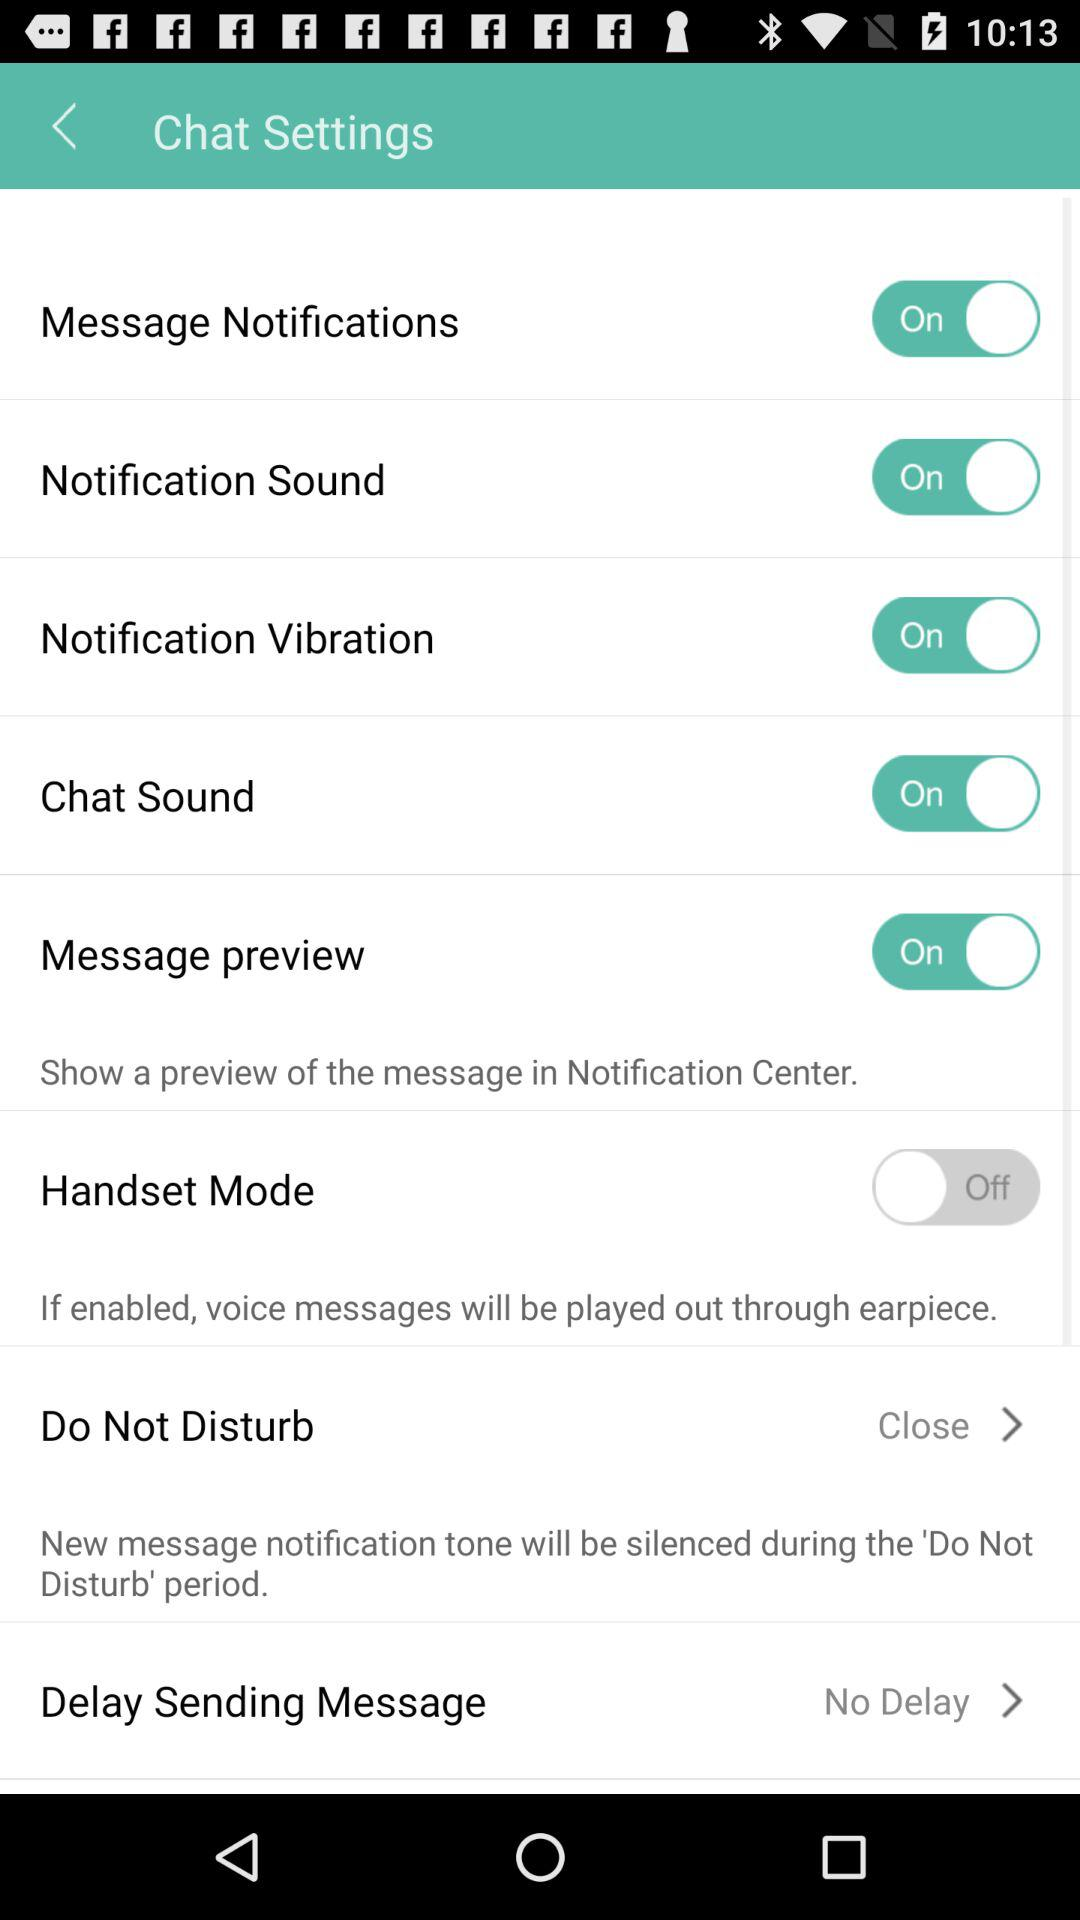What is the status of the "Chat Sound"? The status of the "Chat Sound" is "on". 